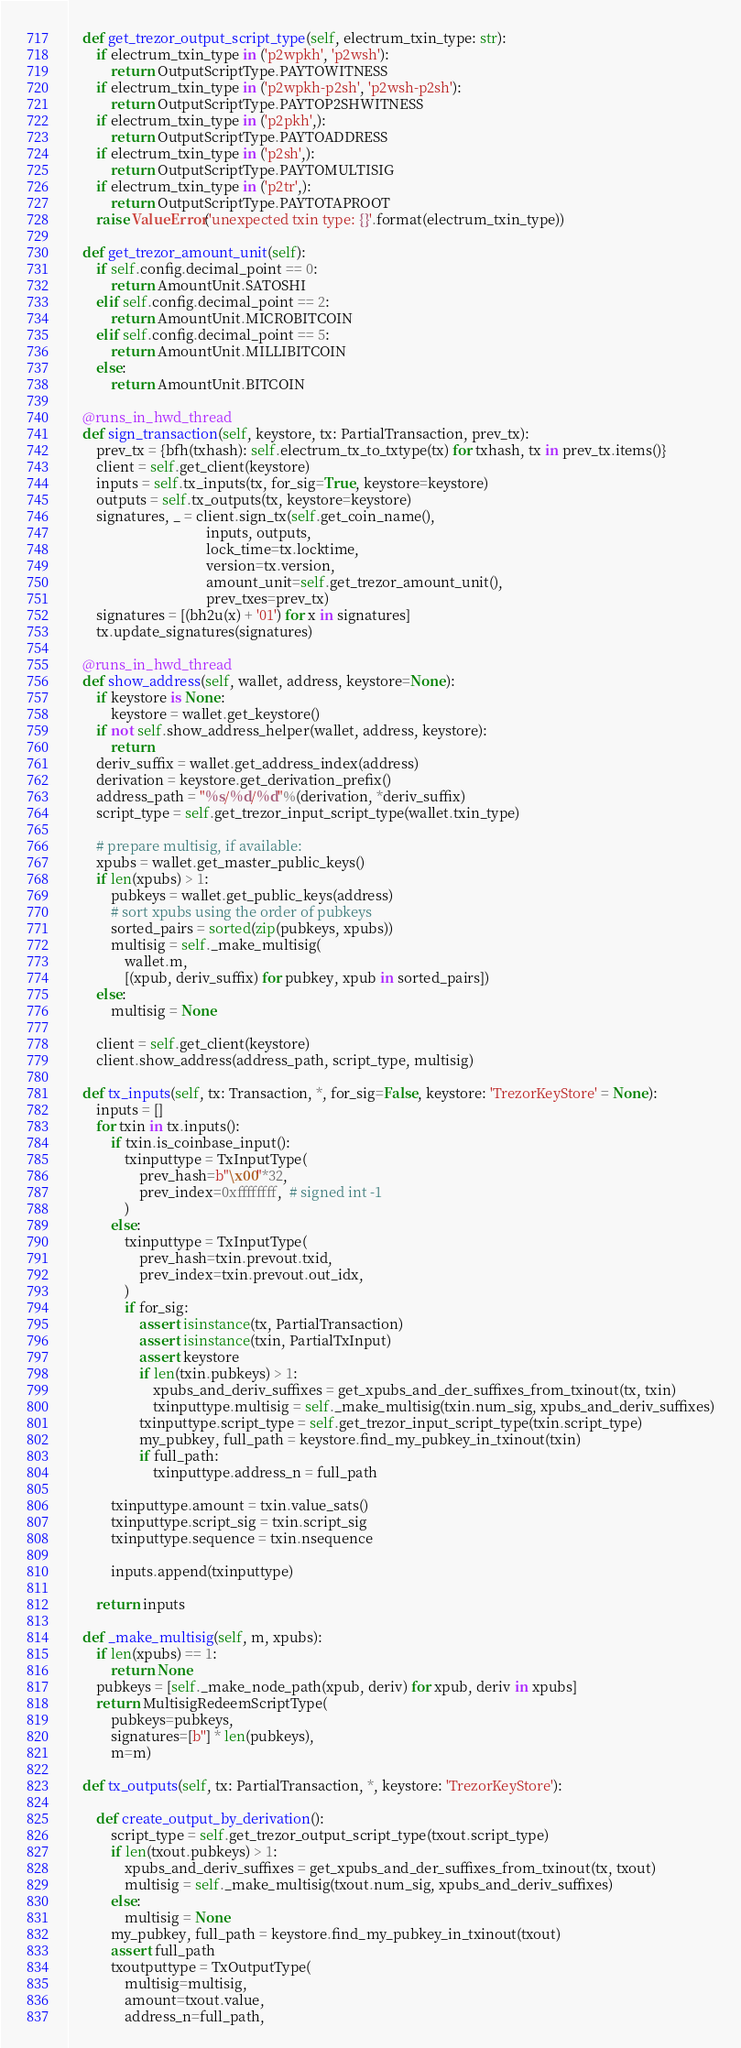<code> <loc_0><loc_0><loc_500><loc_500><_Python_>    def get_trezor_output_script_type(self, electrum_txin_type: str):
        if electrum_txin_type in ('p2wpkh', 'p2wsh'):
            return OutputScriptType.PAYTOWITNESS
        if electrum_txin_type in ('p2wpkh-p2sh', 'p2wsh-p2sh'):
            return OutputScriptType.PAYTOP2SHWITNESS
        if electrum_txin_type in ('p2pkh',):
            return OutputScriptType.PAYTOADDRESS
        if electrum_txin_type in ('p2sh',):
            return OutputScriptType.PAYTOMULTISIG
        if electrum_txin_type in ('p2tr',):
            return OutputScriptType.PAYTOTAPROOT
        raise ValueError('unexpected txin type: {}'.format(electrum_txin_type))

    def get_trezor_amount_unit(self):
        if self.config.decimal_point == 0:
            return AmountUnit.SATOSHI
        elif self.config.decimal_point == 2:
            return AmountUnit.MICROBITCOIN
        elif self.config.decimal_point == 5:
            return AmountUnit.MILLIBITCOIN
        else:
            return AmountUnit.BITCOIN

    @runs_in_hwd_thread
    def sign_transaction(self, keystore, tx: PartialTransaction, prev_tx):
        prev_tx = {bfh(txhash): self.electrum_tx_to_txtype(tx) for txhash, tx in prev_tx.items()}
        client = self.get_client(keystore)
        inputs = self.tx_inputs(tx, for_sig=True, keystore=keystore)
        outputs = self.tx_outputs(tx, keystore=keystore)
        signatures, _ = client.sign_tx(self.get_coin_name(),
                                       inputs, outputs,
                                       lock_time=tx.locktime,
                                       version=tx.version,
                                       amount_unit=self.get_trezor_amount_unit(),
                                       prev_txes=prev_tx)
        signatures = [(bh2u(x) + '01') for x in signatures]
        tx.update_signatures(signatures)

    @runs_in_hwd_thread
    def show_address(self, wallet, address, keystore=None):
        if keystore is None:
            keystore = wallet.get_keystore()
        if not self.show_address_helper(wallet, address, keystore):
            return
        deriv_suffix = wallet.get_address_index(address)
        derivation = keystore.get_derivation_prefix()
        address_path = "%s/%d/%d"%(derivation, *deriv_suffix)
        script_type = self.get_trezor_input_script_type(wallet.txin_type)

        # prepare multisig, if available:
        xpubs = wallet.get_master_public_keys()
        if len(xpubs) > 1:
            pubkeys = wallet.get_public_keys(address)
            # sort xpubs using the order of pubkeys
            sorted_pairs = sorted(zip(pubkeys, xpubs))
            multisig = self._make_multisig(
                wallet.m,
                [(xpub, deriv_suffix) for pubkey, xpub in sorted_pairs])
        else:
            multisig = None

        client = self.get_client(keystore)
        client.show_address(address_path, script_type, multisig)

    def tx_inputs(self, tx: Transaction, *, for_sig=False, keystore: 'TrezorKeyStore' = None):
        inputs = []
        for txin in tx.inputs():
            if txin.is_coinbase_input():
                txinputtype = TxInputType(
                    prev_hash=b"\x00"*32,
                    prev_index=0xffffffff,  # signed int -1
                )
            else:
                txinputtype = TxInputType(
                    prev_hash=txin.prevout.txid,
                    prev_index=txin.prevout.out_idx,
                )
                if for_sig:
                    assert isinstance(tx, PartialTransaction)
                    assert isinstance(txin, PartialTxInput)
                    assert keystore
                    if len(txin.pubkeys) > 1:
                        xpubs_and_deriv_suffixes = get_xpubs_and_der_suffixes_from_txinout(tx, txin)
                        txinputtype.multisig = self._make_multisig(txin.num_sig, xpubs_and_deriv_suffixes)
                    txinputtype.script_type = self.get_trezor_input_script_type(txin.script_type)
                    my_pubkey, full_path = keystore.find_my_pubkey_in_txinout(txin)
                    if full_path:
                        txinputtype.address_n = full_path

            txinputtype.amount = txin.value_sats()
            txinputtype.script_sig = txin.script_sig
            txinputtype.sequence = txin.nsequence

            inputs.append(txinputtype)

        return inputs

    def _make_multisig(self, m, xpubs):
        if len(xpubs) == 1:
            return None
        pubkeys = [self._make_node_path(xpub, deriv) for xpub, deriv in xpubs]
        return MultisigRedeemScriptType(
            pubkeys=pubkeys,
            signatures=[b''] * len(pubkeys),
            m=m)

    def tx_outputs(self, tx: PartialTransaction, *, keystore: 'TrezorKeyStore'):

        def create_output_by_derivation():
            script_type = self.get_trezor_output_script_type(txout.script_type)
            if len(txout.pubkeys) > 1:
                xpubs_and_deriv_suffixes = get_xpubs_and_der_suffixes_from_txinout(tx, txout)
                multisig = self._make_multisig(txout.num_sig, xpubs_and_deriv_suffixes)
            else:
                multisig = None
            my_pubkey, full_path = keystore.find_my_pubkey_in_txinout(txout)
            assert full_path
            txoutputtype = TxOutputType(
                multisig=multisig,
                amount=txout.value,
                address_n=full_path,</code> 